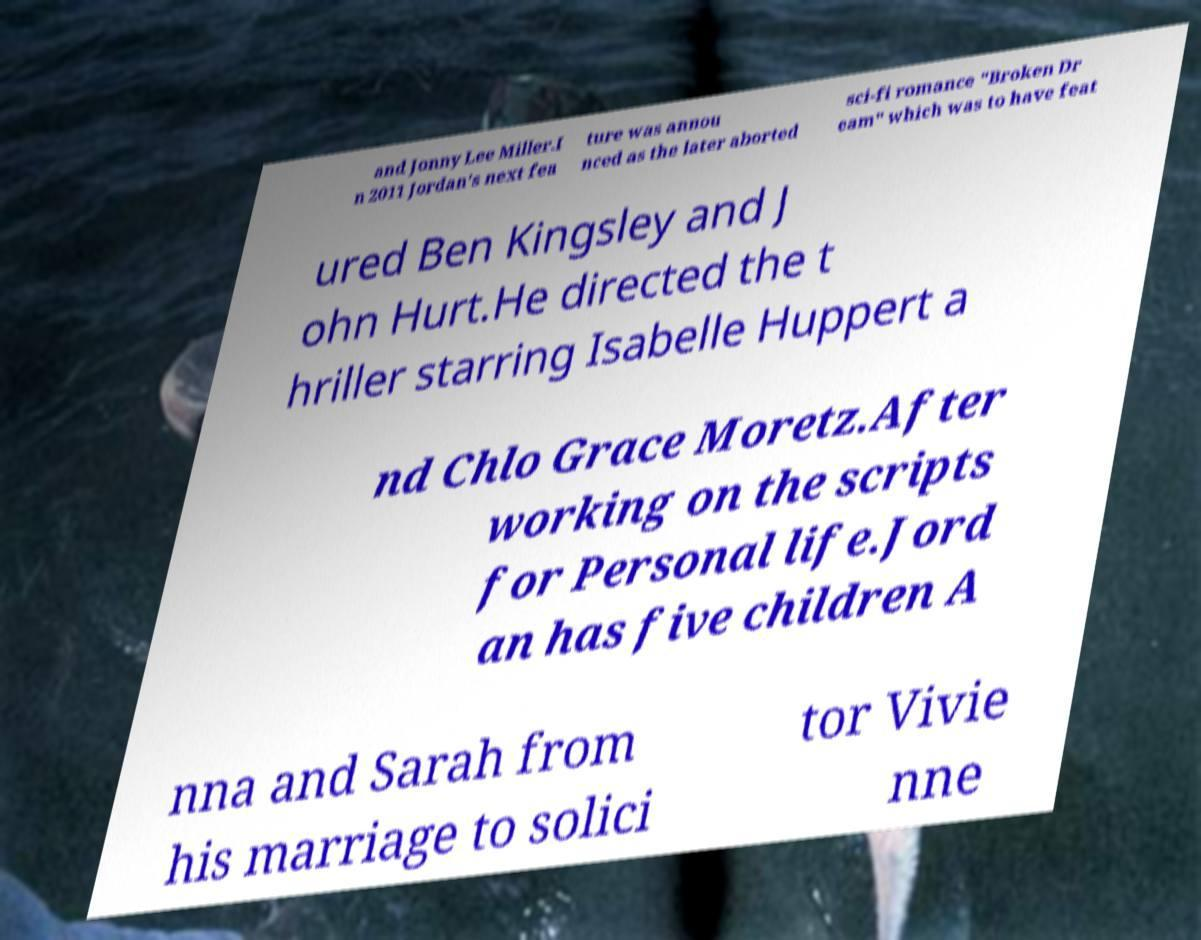I need the written content from this picture converted into text. Can you do that? and Jonny Lee Miller.I n 2011 Jordan's next fea ture was annou nced as the later aborted sci-fi romance "Broken Dr eam" which was to have feat ured Ben Kingsley and J ohn Hurt.He directed the t hriller starring Isabelle Huppert a nd Chlo Grace Moretz.After working on the scripts for Personal life.Jord an has five children A nna and Sarah from his marriage to solici tor Vivie nne 